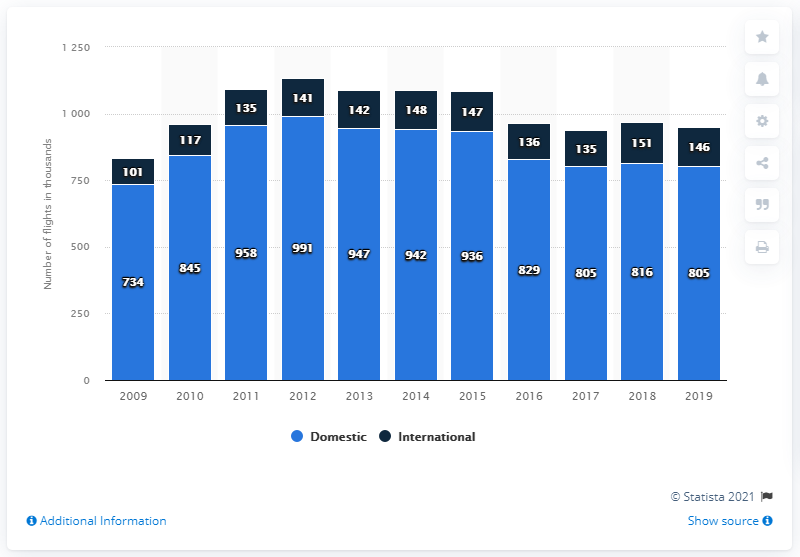Give some essential details in this illustration. In 2016, there were a total of 965 flights. The peak in the total number of flights was reached in 2012. 